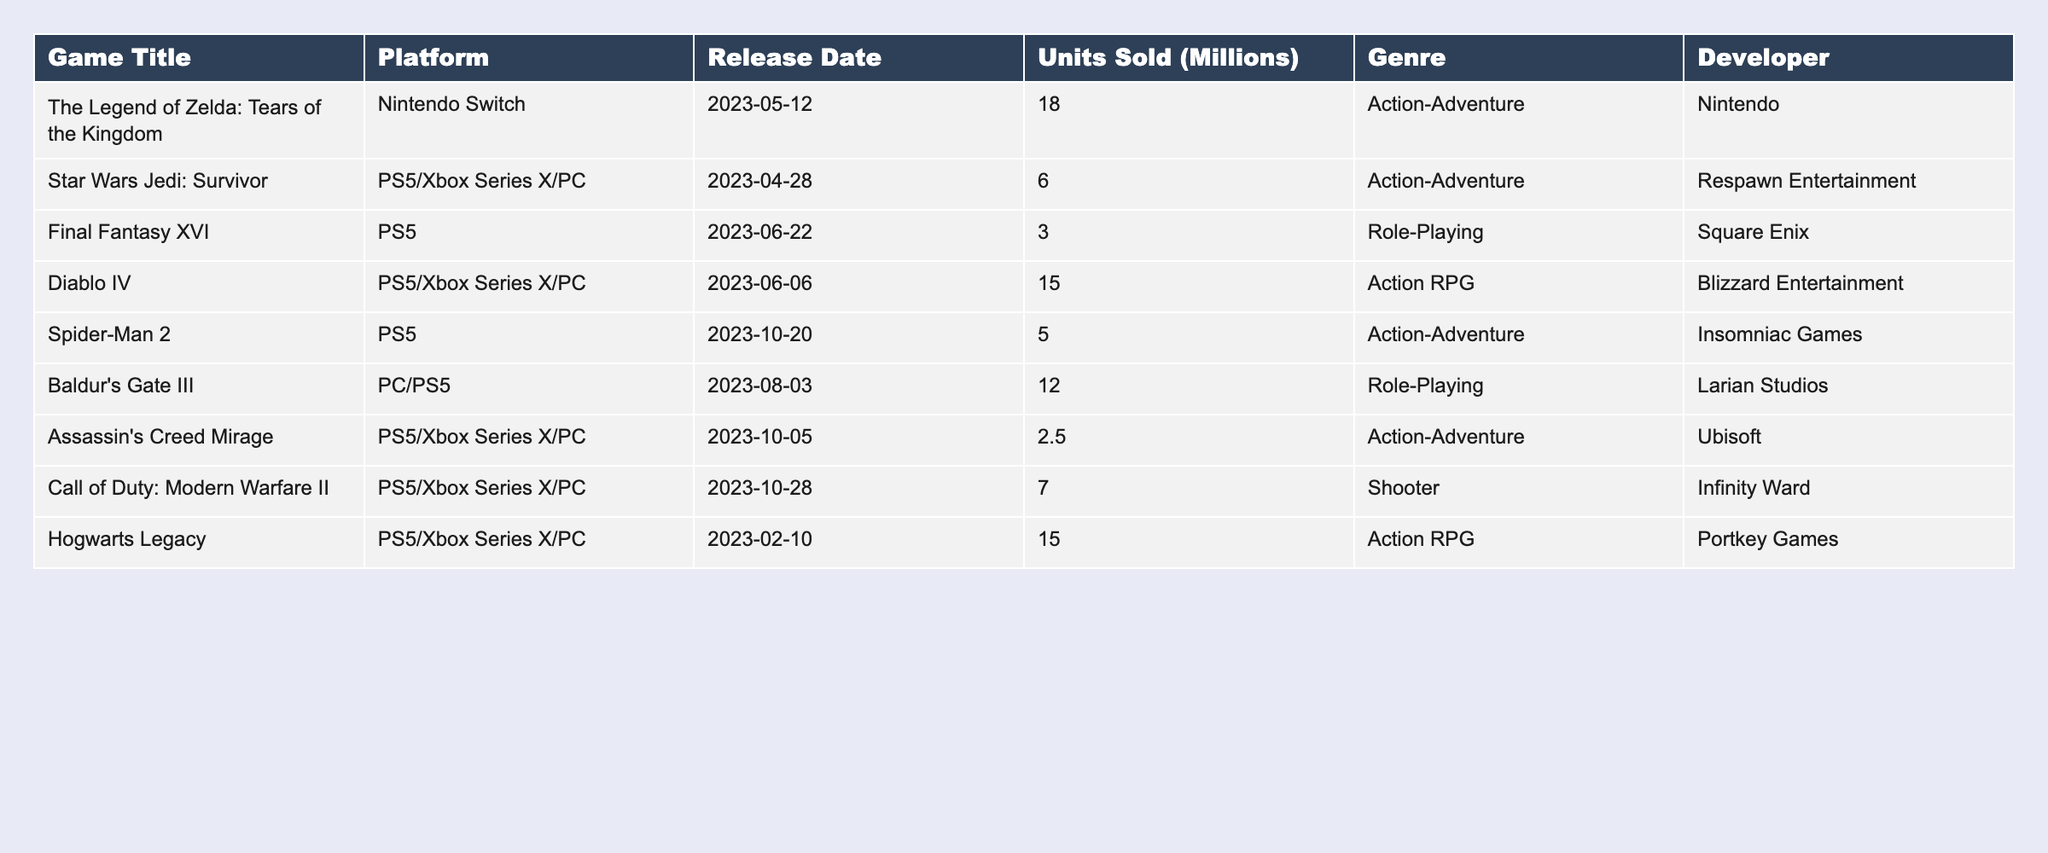What is the highest-selling game in 2023? The table lists the units sold for each game, and the highest value is 18.0 million for "The Legend of Zelda: Tears of the Kingdom."
Answer: 18.0 million Which game sold the least units? Looking at the units sold, "Assassin's Creed Mirage" has the lowest sales at 2.5 million units.
Answer: 2.5 million What is the total number of units sold by all games combined? To find the total, I sum all the units sold: 18.0 + 6.0 + 3.0 + 15.0 + 5.0 + 12.0 + 2.5 + 7.0 + 15.0 = 68.5 million units.
Answer: 68.5 million How many games were released on the PS5 platform? From the table, I count the games listed under the PS5 platform: "Final Fantasy XVI," "Diablo IV," "Spider-Man 2," "Baldur's Gate III," "Assassin's Creed Mirage," "Call of Duty: Modern Warfare II," and "Hogwarts Legacy" totaling 6 games.
Answer: 6 games Which game belongs to the Action RPG genre? I can check the genre column for the games classified as Action RPG, which includes "Diablo IV" and "Hogwarts Legacy."
Answer: Diablo IV, Hogwarts Legacy What is the average units sold for genre Action-Adventure? For Action-Adventure, I identify three titles: "The Legend of Zelda: Tears of the Kingdom" (18.0), "Star Wars Jedi: Survivor" (6.0), and "Spider-Man 2" (5.0). The average is (18.0 + 6.0 + 5.0) / 3 = 29.0 / 3 = 9.67 million.
Answer: 9.67 million Did "Baldur's Gate III" sell more than "Final Fantasy XVI"? I compare their sales: "Baldur's Gate III" sold 12.0 million units and "Final Fantasy XVI" sold 3.0 million units, confirming that Baldur's Gate III sold more.
Answer: Yes Which game was released the latest in 2023? The table shows the release dates, and "Spider-Man 2" was released on October 20, 2023, making it the latest release.
Answer: Spider-Man 2 How many units were sold by the PC platform games combined? The games for PC are "Baldur's Gate III," "Diablo IV," and "Hogwarts Legacy," with sales of 12.0, 15.0, and 15.0 million units respectively. So, the total is 12.0 + 15.0 + 15.0 = 42.0 million.
Answer: 42.0 million Which developer made "Hogwarts Legacy"? Checking the developer column, I find that "Hogwarts Legacy" was developed by Portkey Games.
Answer: Portkey Games Is there any game released before March 2023? I check the release dates of the games listed and see that  "Hogwarts Legacy," released on February 10, 2023, is before March 2023.
Answer: Yes 